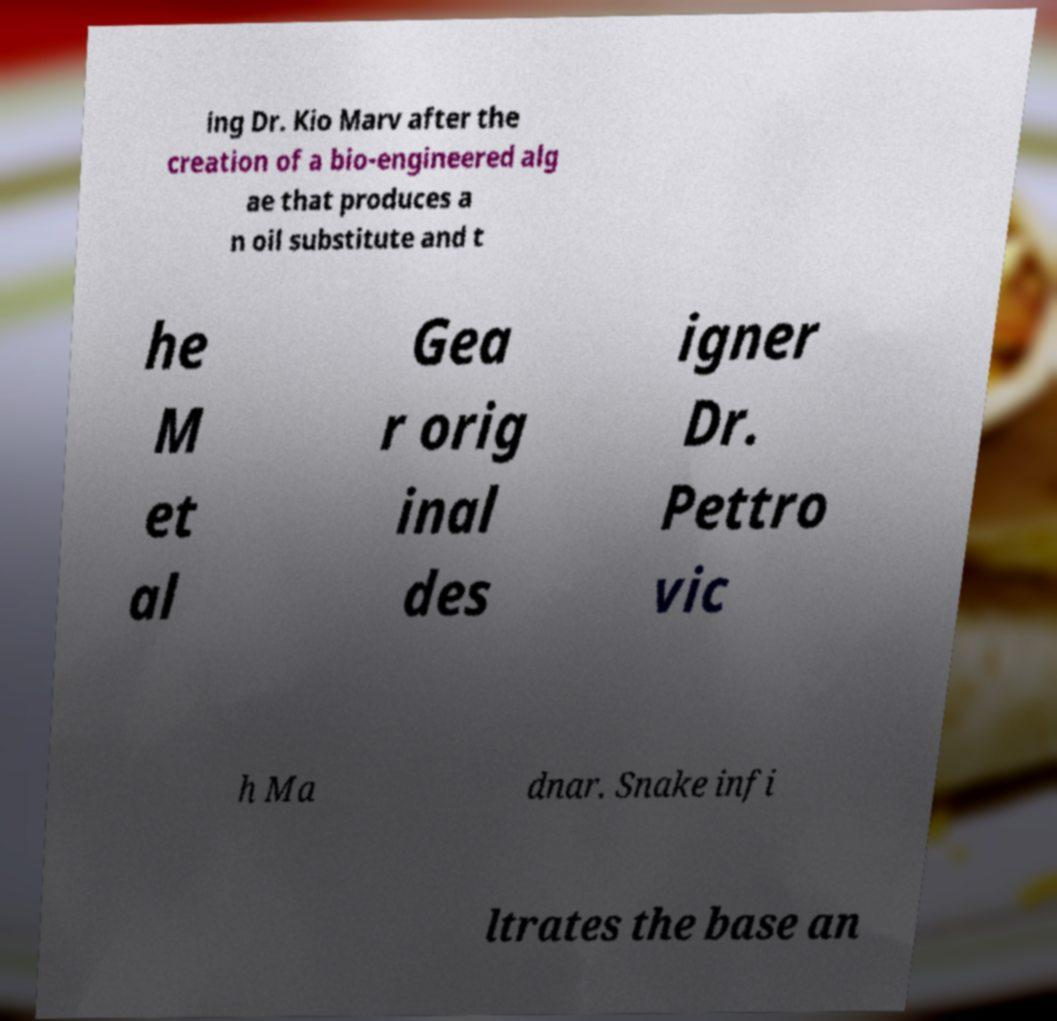Please read and relay the text visible in this image. What does it say? ing Dr. Kio Marv after the creation of a bio-engineered alg ae that produces a n oil substitute and t he M et al Gea r orig inal des igner Dr. Pettro vic h Ma dnar. Snake infi ltrates the base an 